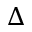Convert formula to latex. <formula><loc_0><loc_0><loc_500><loc_500>\Delta</formula> 